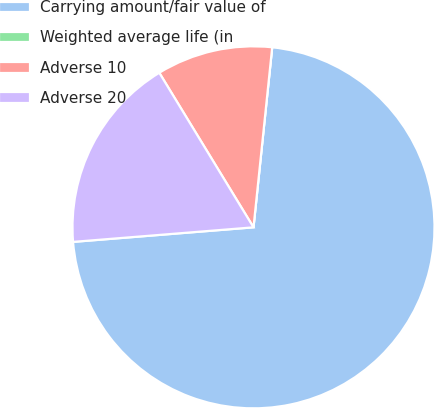Convert chart to OTSL. <chart><loc_0><loc_0><loc_500><loc_500><pie_chart><fcel>Carrying amount/fair value of<fcel>Weighted average life (in<fcel>Adverse 10<fcel>Adverse 20<nl><fcel>72.07%<fcel>0.0%<fcel>10.36%<fcel>17.57%<nl></chart> 